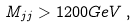<formula> <loc_0><loc_0><loc_500><loc_500>M _ { j j } > 1 2 0 0 G e V \, ,</formula> 